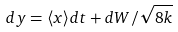Convert formula to latex. <formula><loc_0><loc_0><loc_500><loc_500>d y = \langle x \rangle d t + d W / { \sqrt { 8 k } }</formula> 